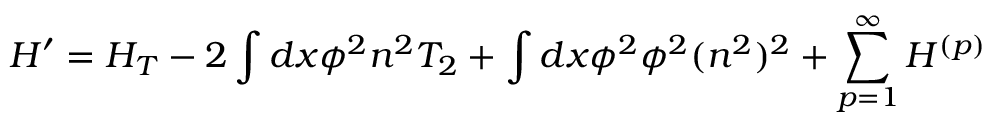Convert formula to latex. <formula><loc_0><loc_0><loc_500><loc_500>H ^ { \prime } = H _ { T } - 2 \int d x \phi ^ { 2 } n ^ { 2 } T _ { 2 } + \int d x \phi ^ { 2 } \phi ^ { 2 } ( n ^ { 2 } ) ^ { 2 } + \sum _ { p = 1 } ^ { \infty } H ^ { ( p ) }</formula> 